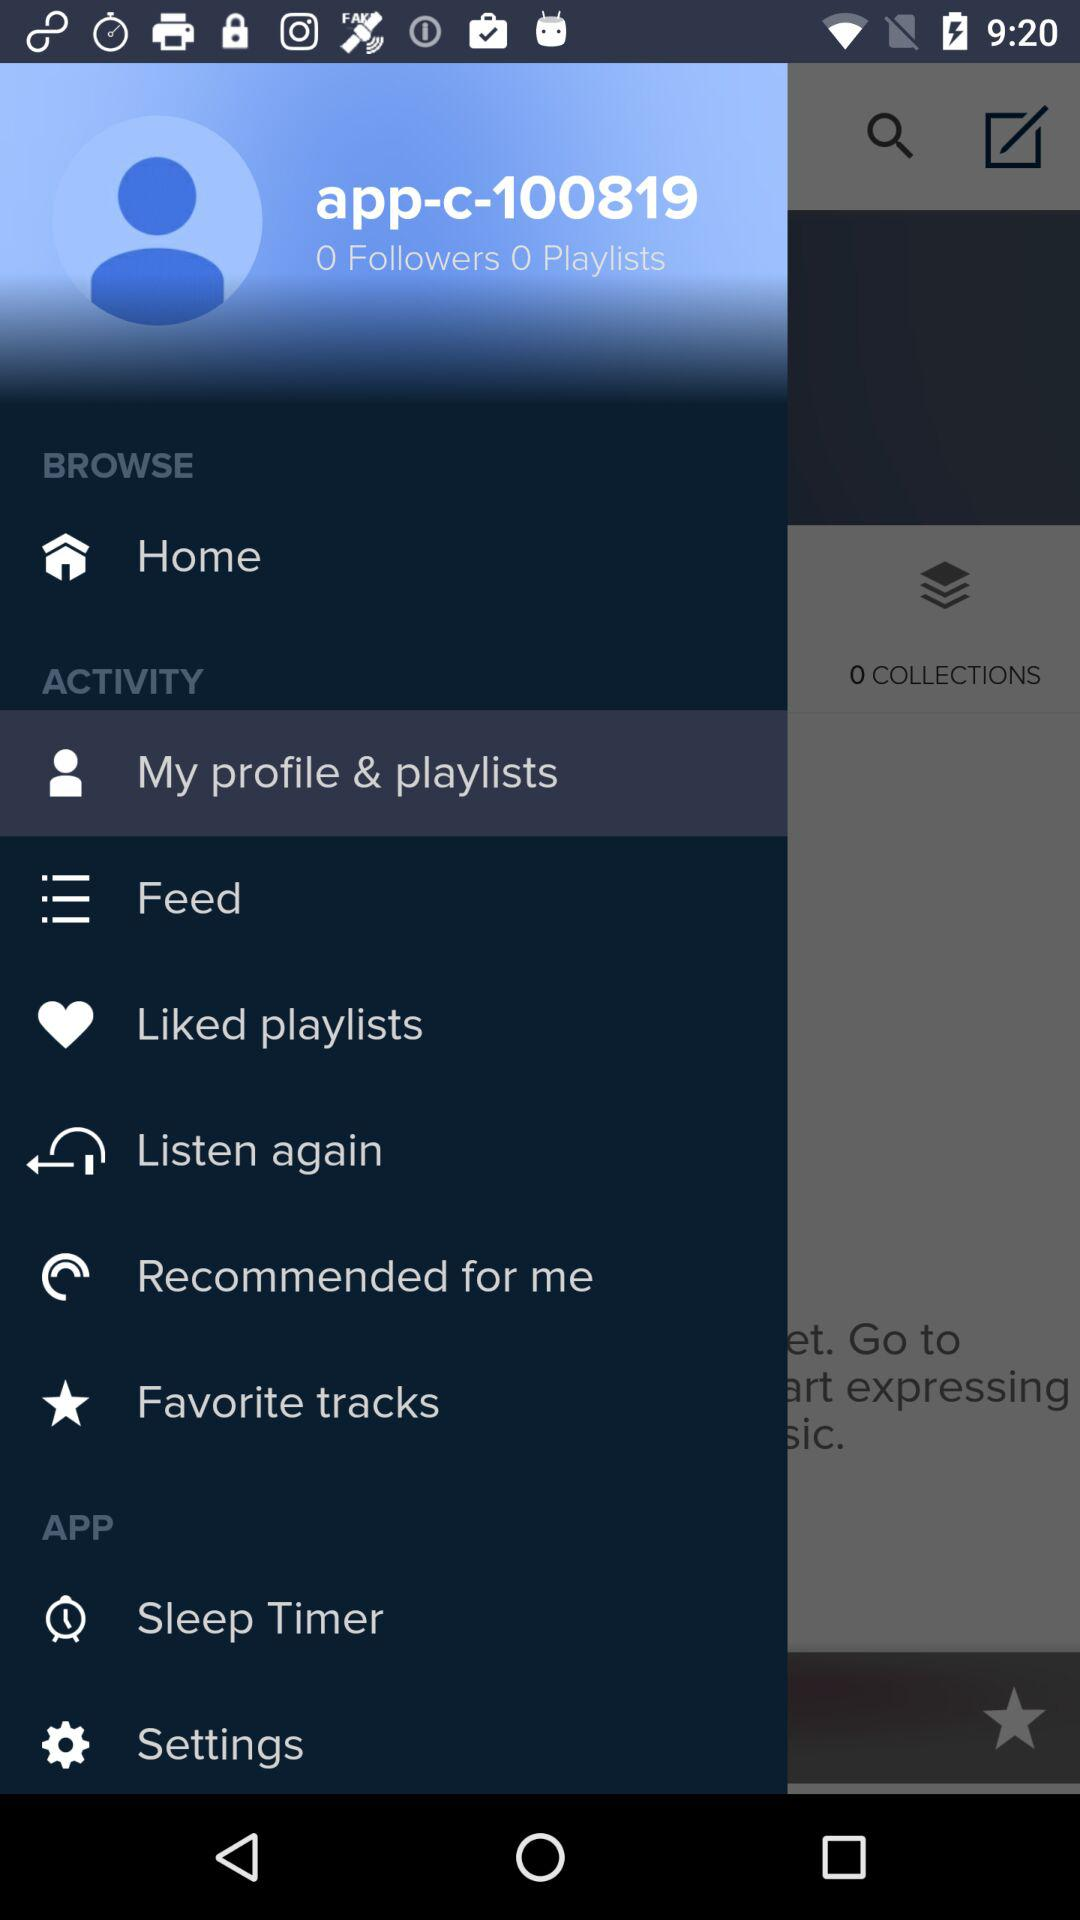What is the selected item in the menu? The selected item in the menu is "My profile & playlists". 